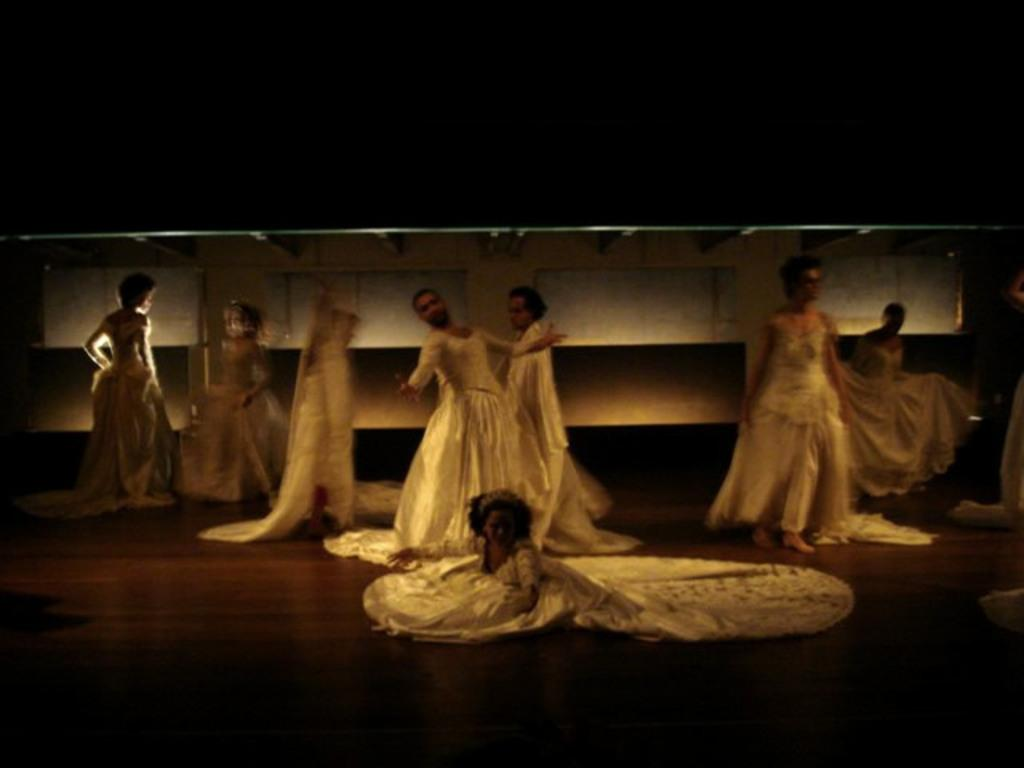What can be seen in the image? There are people standing in the image. What are the people wearing? The people are wearing white dresses. Is there anyone sitting in the image? Yes, there is a person sitting at the front. How many bubbles can be seen in the image? There are no bubbles present in the image. How many legs does the person sitting at the front have? The person sitting at the front has two legs, as is typical for humans. 